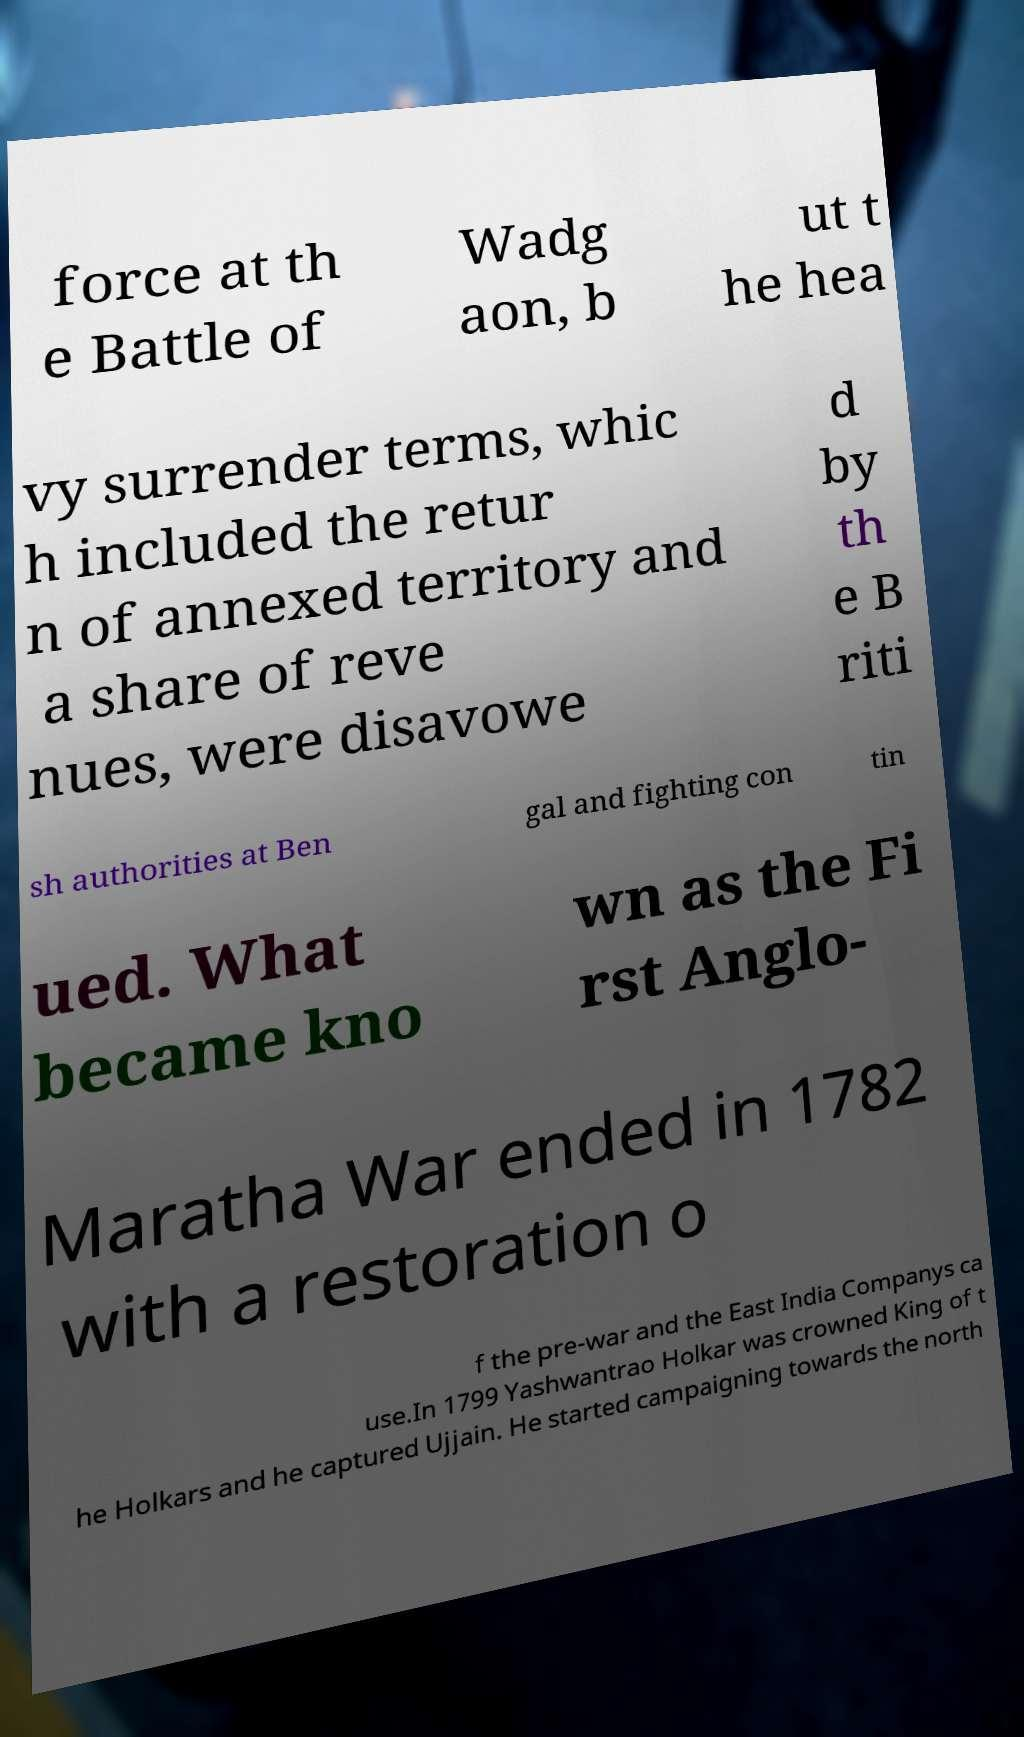Could you extract and type out the text from this image? force at th e Battle of Wadg aon, b ut t he hea vy surrender terms, whic h included the retur n of annexed territory and a share of reve nues, were disavowe d by th e B riti sh authorities at Ben gal and fighting con tin ued. What became kno wn as the Fi rst Anglo- Maratha War ended in 1782 with a restoration o f the pre-war and the East India Companys ca use.In 1799 Yashwantrao Holkar was crowned King of t he Holkars and he captured Ujjain. He started campaigning towards the north 